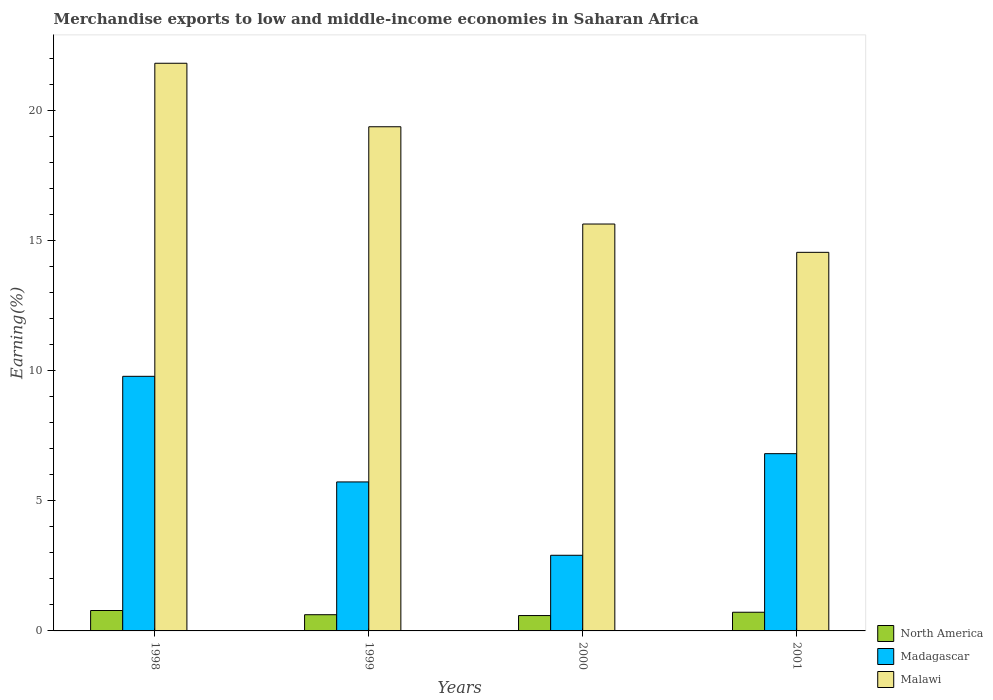How many different coloured bars are there?
Offer a very short reply. 3. Are the number of bars per tick equal to the number of legend labels?
Your answer should be very brief. Yes. How many bars are there on the 1st tick from the left?
Provide a succinct answer. 3. What is the label of the 3rd group of bars from the left?
Provide a short and direct response. 2000. In how many cases, is the number of bars for a given year not equal to the number of legend labels?
Provide a short and direct response. 0. What is the percentage of amount earned from merchandise exports in North America in 1999?
Keep it short and to the point. 0.62. Across all years, what is the maximum percentage of amount earned from merchandise exports in Malawi?
Provide a short and direct response. 21.82. Across all years, what is the minimum percentage of amount earned from merchandise exports in North America?
Make the answer very short. 0.59. In which year was the percentage of amount earned from merchandise exports in Malawi minimum?
Your answer should be compact. 2001. What is the total percentage of amount earned from merchandise exports in North America in the graph?
Your response must be concise. 2.72. What is the difference between the percentage of amount earned from merchandise exports in North America in 1998 and that in 2000?
Provide a short and direct response. 0.19. What is the difference between the percentage of amount earned from merchandise exports in North America in 2000 and the percentage of amount earned from merchandise exports in Malawi in 1998?
Keep it short and to the point. -21.23. What is the average percentage of amount earned from merchandise exports in North America per year?
Your answer should be compact. 0.68. In the year 1998, what is the difference between the percentage of amount earned from merchandise exports in Madagascar and percentage of amount earned from merchandise exports in Malawi?
Offer a very short reply. -12.03. What is the ratio of the percentage of amount earned from merchandise exports in Madagascar in 1998 to that in 2000?
Provide a succinct answer. 3.37. Is the difference between the percentage of amount earned from merchandise exports in Madagascar in 2000 and 2001 greater than the difference between the percentage of amount earned from merchandise exports in Malawi in 2000 and 2001?
Ensure brevity in your answer.  No. What is the difference between the highest and the second highest percentage of amount earned from merchandise exports in North America?
Offer a very short reply. 0.07. What is the difference between the highest and the lowest percentage of amount earned from merchandise exports in Malawi?
Your response must be concise. 7.27. What does the 2nd bar from the left in 1998 represents?
Provide a short and direct response. Madagascar. What does the 1st bar from the right in 1999 represents?
Give a very brief answer. Malawi. Are all the bars in the graph horizontal?
Keep it short and to the point. No. How many years are there in the graph?
Provide a short and direct response. 4. What is the difference between two consecutive major ticks on the Y-axis?
Provide a succinct answer. 5. Does the graph contain grids?
Give a very brief answer. No. Where does the legend appear in the graph?
Offer a terse response. Bottom right. How are the legend labels stacked?
Offer a terse response. Vertical. What is the title of the graph?
Make the answer very short. Merchandise exports to low and middle-income economies in Saharan Africa. What is the label or title of the Y-axis?
Provide a short and direct response. Earning(%). What is the Earning(%) of North America in 1998?
Make the answer very short. 0.78. What is the Earning(%) of Madagascar in 1998?
Make the answer very short. 9.79. What is the Earning(%) in Malawi in 1998?
Your answer should be compact. 21.82. What is the Earning(%) of North America in 1999?
Your response must be concise. 0.62. What is the Earning(%) of Madagascar in 1999?
Your answer should be very brief. 5.73. What is the Earning(%) of Malawi in 1999?
Provide a short and direct response. 19.38. What is the Earning(%) in North America in 2000?
Give a very brief answer. 0.59. What is the Earning(%) of Madagascar in 2000?
Keep it short and to the point. 2.91. What is the Earning(%) in Malawi in 2000?
Your answer should be compact. 15.64. What is the Earning(%) of North America in 2001?
Your response must be concise. 0.72. What is the Earning(%) of Madagascar in 2001?
Offer a very short reply. 6.81. What is the Earning(%) in Malawi in 2001?
Give a very brief answer. 14.55. Across all years, what is the maximum Earning(%) of North America?
Keep it short and to the point. 0.78. Across all years, what is the maximum Earning(%) of Madagascar?
Provide a succinct answer. 9.79. Across all years, what is the maximum Earning(%) of Malawi?
Offer a very short reply. 21.82. Across all years, what is the minimum Earning(%) of North America?
Provide a short and direct response. 0.59. Across all years, what is the minimum Earning(%) of Madagascar?
Give a very brief answer. 2.91. Across all years, what is the minimum Earning(%) in Malawi?
Provide a succinct answer. 14.55. What is the total Earning(%) of North America in the graph?
Keep it short and to the point. 2.72. What is the total Earning(%) of Madagascar in the graph?
Your answer should be very brief. 25.24. What is the total Earning(%) in Malawi in the graph?
Offer a very short reply. 71.4. What is the difference between the Earning(%) of North America in 1998 and that in 1999?
Offer a very short reply. 0.16. What is the difference between the Earning(%) in Madagascar in 1998 and that in 1999?
Provide a short and direct response. 4.06. What is the difference between the Earning(%) of Malawi in 1998 and that in 1999?
Offer a terse response. 2.44. What is the difference between the Earning(%) in North America in 1998 and that in 2000?
Offer a terse response. 0.19. What is the difference between the Earning(%) in Madagascar in 1998 and that in 2000?
Offer a terse response. 6.88. What is the difference between the Earning(%) of Malawi in 1998 and that in 2000?
Offer a terse response. 6.18. What is the difference between the Earning(%) of North America in 1998 and that in 2001?
Your response must be concise. 0.07. What is the difference between the Earning(%) in Madagascar in 1998 and that in 2001?
Ensure brevity in your answer.  2.97. What is the difference between the Earning(%) in Malawi in 1998 and that in 2001?
Offer a terse response. 7.27. What is the difference between the Earning(%) of North America in 1999 and that in 2000?
Your answer should be compact. 0.03. What is the difference between the Earning(%) of Madagascar in 1999 and that in 2000?
Offer a terse response. 2.82. What is the difference between the Earning(%) of Malawi in 1999 and that in 2000?
Make the answer very short. 3.74. What is the difference between the Earning(%) of North America in 1999 and that in 2001?
Offer a terse response. -0.09. What is the difference between the Earning(%) in Madagascar in 1999 and that in 2001?
Offer a terse response. -1.09. What is the difference between the Earning(%) in Malawi in 1999 and that in 2001?
Your response must be concise. 4.83. What is the difference between the Earning(%) in North America in 2000 and that in 2001?
Your answer should be compact. -0.13. What is the difference between the Earning(%) in Madagascar in 2000 and that in 2001?
Your response must be concise. -3.91. What is the difference between the Earning(%) of Malawi in 2000 and that in 2001?
Give a very brief answer. 1.09. What is the difference between the Earning(%) in North America in 1998 and the Earning(%) in Madagascar in 1999?
Provide a short and direct response. -4.94. What is the difference between the Earning(%) of North America in 1998 and the Earning(%) of Malawi in 1999?
Ensure brevity in your answer.  -18.6. What is the difference between the Earning(%) in Madagascar in 1998 and the Earning(%) in Malawi in 1999?
Offer a terse response. -9.59. What is the difference between the Earning(%) in North America in 1998 and the Earning(%) in Madagascar in 2000?
Ensure brevity in your answer.  -2.12. What is the difference between the Earning(%) of North America in 1998 and the Earning(%) of Malawi in 2000?
Provide a short and direct response. -14.86. What is the difference between the Earning(%) in Madagascar in 1998 and the Earning(%) in Malawi in 2000?
Offer a terse response. -5.85. What is the difference between the Earning(%) in North America in 1998 and the Earning(%) in Madagascar in 2001?
Keep it short and to the point. -6.03. What is the difference between the Earning(%) in North America in 1998 and the Earning(%) in Malawi in 2001?
Make the answer very short. -13.77. What is the difference between the Earning(%) in Madagascar in 1998 and the Earning(%) in Malawi in 2001?
Offer a very short reply. -4.77. What is the difference between the Earning(%) of North America in 1999 and the Earning(%) of Madagascar in 2000?
Make the answer very short. -2.28. What is the difference between the Earning(%) in North America in 1999 and the Earning(%) in Malawi in 2000?
Offer a very short reply. -15.02. What is the difference between the Earning(%) in Madagascar in 1999 and the Earning(%) in Malawi in 2000?
Offer a very short reply. -9.91. What is the difference between the Earning(%) in North America in 1999 and the Earning(%) in Madagascar in 2001?
Provide a short and direct response. -6.19. What is the difference between the Earning(%) of North America in 1999 and the Earning(%) of Malawi in 2001?
Provide a short and direct response. -13.93. What is the difference between the Earning(%) in Madagascar in 1999 and the Earning(%) in Malawi in 2001?
Ensure brevity in your answer.  -8.83. What is the difference between the Earning(%) of North America in 2000 and the Earning(%) of Madagascar in 2001?
Your answer should be very brief. -6.22. What is the difference between the Earning(%) in North America in 2000 and the Earning(%) in Malawi in 2001?
Offer a very short reply. -13.96. What is the difference between the Earning(%) of Madagascar in 2000 and the Earning(%) of Malawi in 2001?
Offer a terse response. -11.64. What is the average Earning(%) in North America per year?
Ensure brevity in your answer.  0.68. What is the average Earning(%) of Madagascar per year?
Offer a terse response. 6.31. What is the average Earning(%) in Malawi per year?
Your response must be concise. 17.85. In the year 1998, what is the difference between the Earning(%) in North America and Earning(%) in Madagascar?
Offer a terse response. -9. In the year 1998, what is the difference between the Earning(%) of North America and Earning(%) of Malawi?
Provide a succinct answer. -21.04. In the year 1998, what is the difference between the Earning(%) of Madagascar and Earning(%) of Malawi?
Offer a very short reply. -12.03. In the year 1999, what is the difference between the Earning(%) in North America and Earning(%) in Madagascar?
Offer a very short reply. -5.1. In the year 1999, what is the difference between the Earning(%) in North America and Earning(%) in Malawi?
Give a very brief answer. -18.76. In the year 1999, what is the difference between the Earning(%) in Madagascar and Earning(%) in Malawi?
Offer a very short reply. -13.65. In the year 2000, what is the difference between the Earning(%) of North America and Earning(%) of Madagascar?
Offer a very short reply. -2.32. In the year 2000, what is the difference between the Earning(%) of North America and Earning(%) of Malawi?
Your response must be concise. -15.05. In the year 2000, what is the difference between the Earning(%) of Madagascar and Earning(%) of Malawi?
Your response must be concise. -12.73. In the year 2001, what is the difference between the Earning(%) of North America and Earning(%) of Madagascar?
Give a very brief answer. -6.1. In the year 2001, what is the difference between the Earning(%) of North America and Earning(%) of Malawi?
Provide a short and direct response. -13.83. In the year 2001, what is the difference between the Earning(%) of Madagascar and Earning(%) of Malawi?
Make the answer very short. -7.74. What is the ratio of the Earning(%) in North America in 1998 to that in 1999?
Provide a short and direct response. 1.26. What is the ratio of the Earning(%) in Madagascar in 1998 to that in 1999?
Give a very brief answer. 1.71. What is the ratio of the Earning(%) of Malawi in 1998 to that in 1999?
Make the answer very short. 1.13. What is the ratio of the Earning(%) in North America in 1998 to that in 2000?
Your answer should be compact. 1.33. What is the ratio of the Earning(%) of Madagascar in 1998 to that in 2000?
Your response must be concise. 3.37. What is the ratio of the Earning(%) in Malawi in 1998 to that in 2000?
Make the answer very short. 1.4. What is the ratio of the Earning(%) in North America in 1998 to that in 2001?
Your response must be concise. 1.09. What is the ratio of the Earning(%) in Madagascar in 1998 to that in 2001?
Make the answer very short. 1.44. What is the ratio of the Earning(%) of Malawi in 1998 to that in 2001?
Give a very brief answer. 1.5. What is the ratio of the Earning(%) of North America in 1999 to that in 2000?
Offer a very short reply. 1.06. What is the ratio of the Earning(%) of Madagascar in 1999 to that in 2000?
Keep it short and to the point. 1.97. What is the ratio of the Earning(%) in Malawi in 1999 to that in 2000?
Give a very brief answer. 1.24. What is the ratio of the Earning(%) in North America in 1999 to that in 2001?
Offer a terse response. 0.87. What is the ratio of the Earning(%) in Madagascar in 1999 to that in 2001?
Provide a short and direct response. 0.84. What is the ratio of the Earning(%) of Malawi in 1999 to that in 2001?
Make the answer very short. 1.33. What is the ratio of the Earning(%) of North America in 2000 to that in 2001?
Your answer should be very brief. 0.82. What is the ratio of the Earning(%) of Madagascar in 2000 to that in 2001?
Provide a succinct answer. 0.43. What is the ratio of the Earning(%) in Malawi in 2000 to that in 2001?
Make the answer very short. 1.07. What is the difference between the highest and the second highest Earning(%) of North America?
Provide a succinct answer. 0.07. What is the difference between the highest and the second highest Earning(%) of Madagascar?
Offer a terse response. 2.97. What is the difference between the highest and the second highest Earning(%) of Malawi?
Ensure brevity in your answer.  2.44. What is the difference between the highest and the lowest Earning(%) in North America?
Keep it short and to the point. 0.19. What is the difference between the highest and the lowest Earning(%) in Madagascar?
Your response must be concise. 6.88. What is the difference between the highest and the lowest Earning(%) of Malawi?
Your answer should be compact. 7.27. 